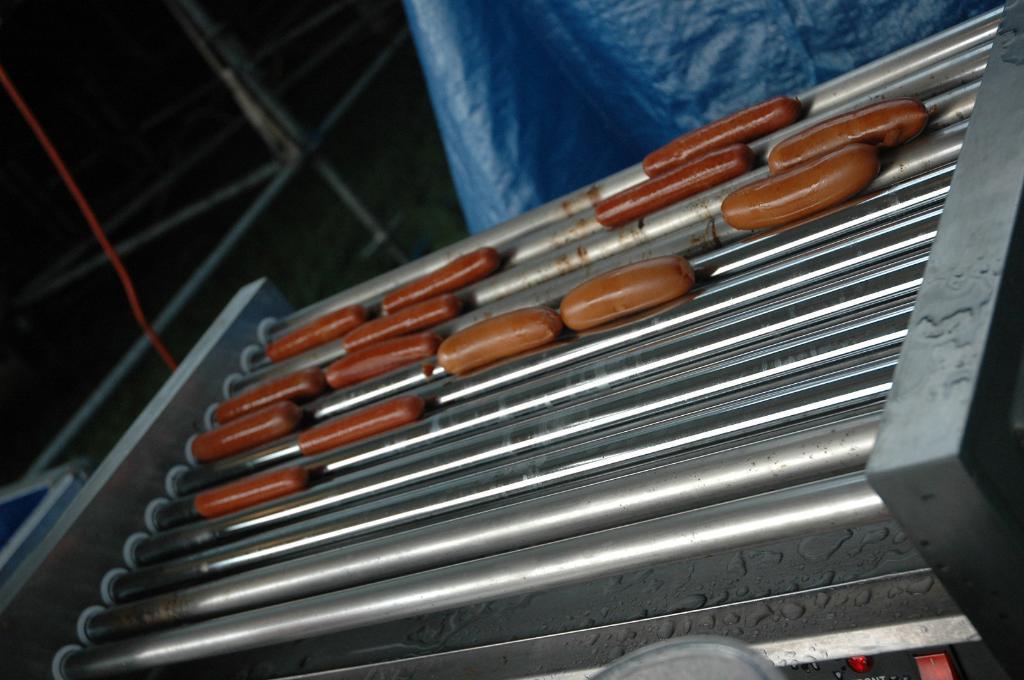Can you describe this image briefly? This image consists of food which is in the center. In the background there is a sheet which is blue in colour and there is a stand. 